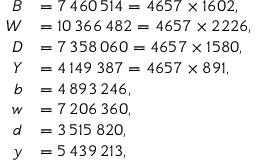<formula> <loc_0><loc_0><loc_500><loc_500>{ \begin{array} { r l } { B } & { = 7 \, 4 6 0 \, 5 1 4 = 4 6 5 7 \times 1 6 0 2 , } \\ { W } & { = 1 0 \, 3 6 6 \, 4 8 2 = 4 6 5 7 \times 2 2 2 6 , } \\ { D } & { = 7 \, 3 5 8 \, 0 6 0 = 4 6 5 7 \times 1 5 8 0 , } \\ { Y } & { = 4 \, 1 4 9 \, 3 8 7 = 4 6 5 7 \times 8 9 1 , } \\ { b } & { = 4 \, 8 9 3 \, 2 4 6 , } \\ { w } & { = 7 \, 2 0 6 \, 3 6 0 , } \\ { d } & { = 3 \, 5 1 5 \, 8 2 0 , } \\ { y } & { = 5 \, 4 3 9 \, 2 1 3 , } \end{array} }</formula> 